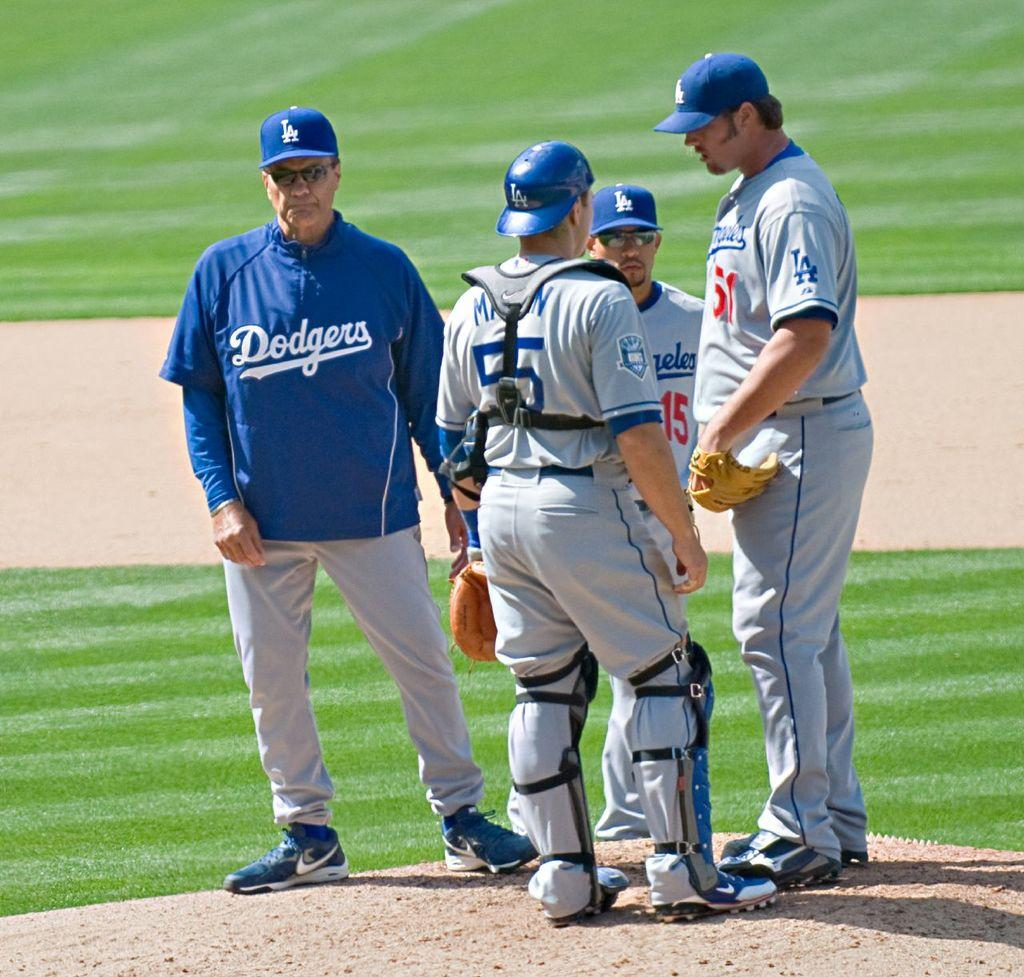Provide a one-sentence caption for the provided image. A trio of Dodgers players confer as one of their coaches looks on. 